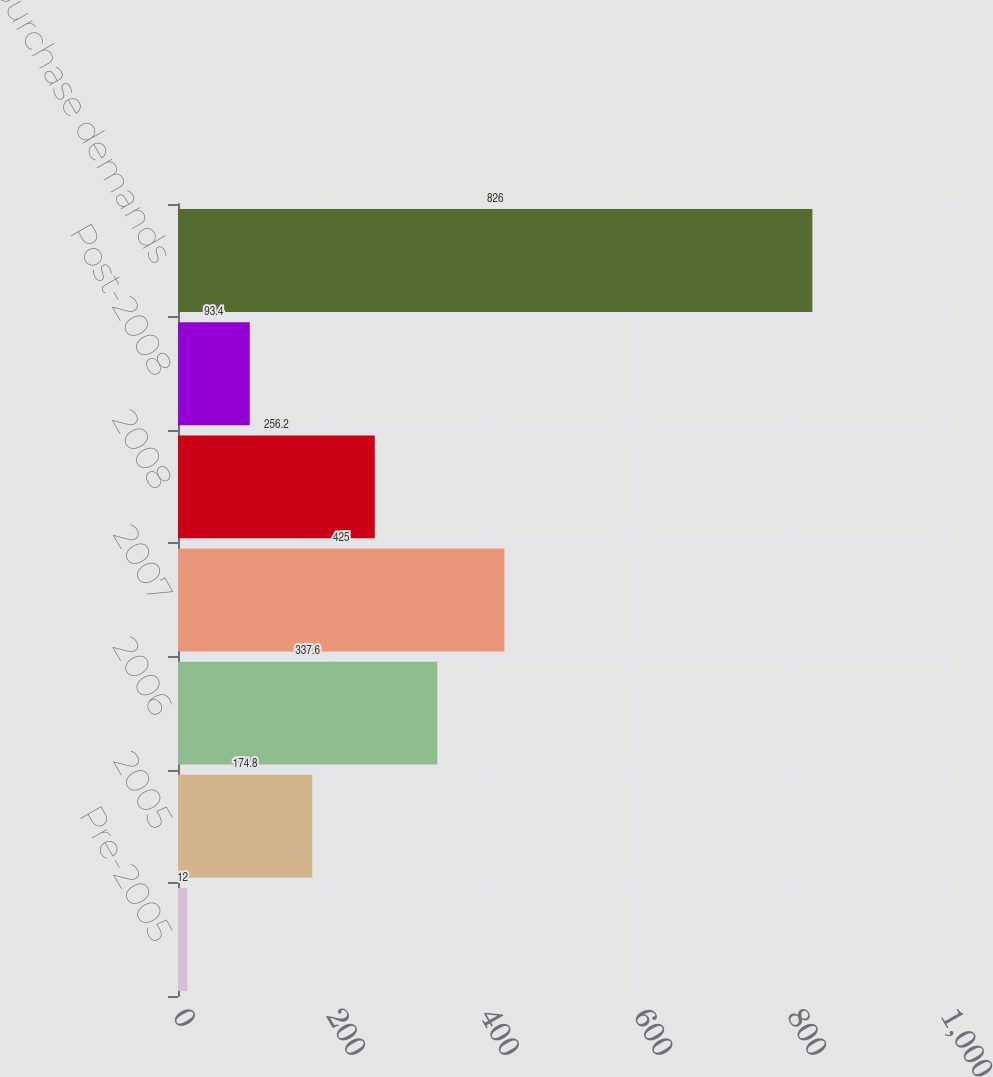<chart> <loc_0><loc_0><loc_500><loc_500><bar_chart><fcel>Pre-2005<fcel>2005<fcel>2006<fcel>2007<fcel>2008<fcel>Post-2008<fcel>Total repurchase demands<nl><fcel>12<fcel>174.8<fcel>337.6<fcel>425<fcel>256.2<fcel>93.4<fcel>826<nl></chart> 